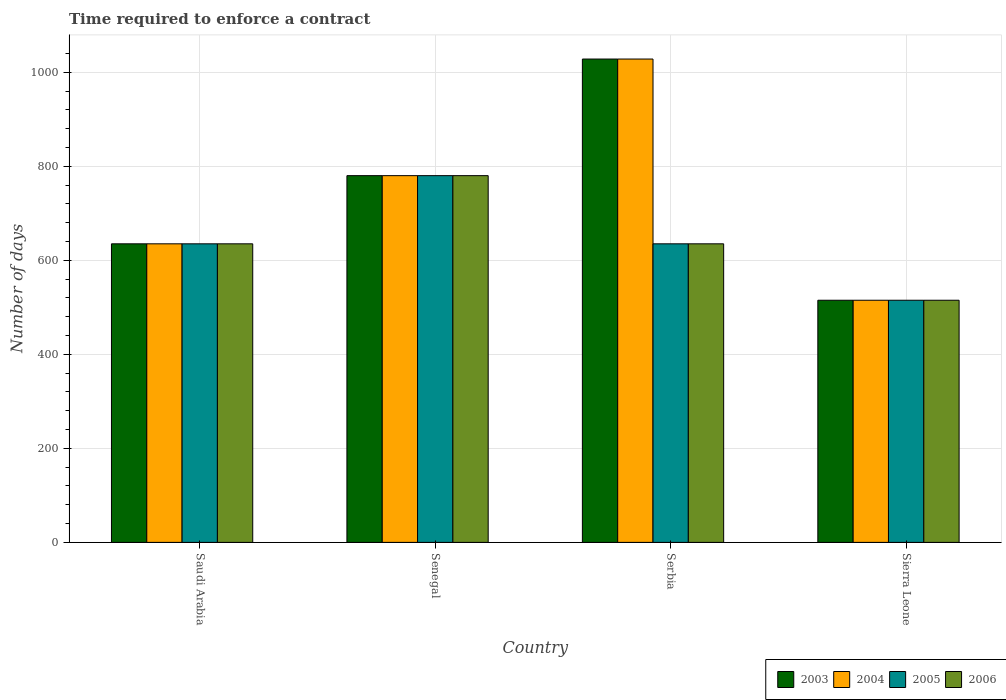How many different coloured bars are there?
Offer a very short reply. 4. What is the label of the 1st group of bars from the left?
Give a very brief answer. Saudi Arabia. In how many cases, is the number of bars for a given country not equal to the number of legend labels?
Offer a very short reply. 0. What is the number of days required to enforce a contract in 2004 in Serbia?
Your answer should be compact. 1028. Across all countries, what is the maximum number of days required to enforce a contract in 2003?
Offer a very short reply. 1028. Across all countries, what is the minimum number of days required to enforce a contract in 2003?
Give a very brief answer. 515. In which country was the number of days required to enforce a contract in 2003 maximum?
Provide a short and direct response. Serbia. In which country was the number of days required to enforce a contract in 2005 minimum?
Keep it short and to the point. Sierra Leone. What is the total number of days required to enforce a contract in 2006 in the graph?
Make the answer very short. 2565. What is the difference between the number of days required to enforce a contract in 2006 in Senegal and that in Sierra Leone?
Make the answer very short. 265. What is the difference between the number of days required to enforce a contract in 2005 in Saudi Arabia and the number of days required to enforce a contract in 2004 in Serbia?
Provide a succinct answer. -393. What is the average number of days required to enforce a contract in 2006 per country?
Offer a terse response. 641.25. In how many countries, is the number of days required to enforce a contract in 2006 greater than 560 days?
Ensure brevity in your answer.  3. What is the ratio of the number of days required to enforce a contract in 2006 in Senegal to that in Serbia?
Keep it short and to the point. 1.23. What is the difference between the highest and the second highest number of days required to enforce a contract in 2003?
Provide a short and direct response. -393. What is the difference between the highest and the lowest number of days required to enforce a contract in 2006?
Offer a terse response. 265. Is the sum of the number of days required to enforce a contract in 2004 in Saudi Arabia and Senegal greater than the maximum number of days required to enforce a contract in 2005 across all countries?
Your response must be concise. Yes. What does the 1st bar from the left in Saudi Arabia represents?
Keep it short and to the point. 2003. What does the 4th bar from the right in Senegal represents?
Provide a short and direct response. 2003. Is it the case that in every country, the sum of the number of days required to enforce a contract in 2004 and number of days required to enforce a contract in 2006 is greater than the number of days required to enforce a contract in 2005?
Offer a terse response. Yes. Where does the legend appear in the graph?
Your answer should be very brief. Bottom right. How many legend labels are there?
Give a very brief answer. 4. How are the legend labels stacked?
Give a very brief answer. Horizontal. What is the title of the graph?
Your response must be concise. Time required to enforce a contract. Does "2005" appear as one of the legend labels in the graph?
Provide a short and direct response. Yes. What is the label or title of the Y-axis?
Your response must be concise. Number of days. What is the Number of days in 2003 in Saudi Arabia?
Your response must be concise. 635. What is the Number of days in 2004 in Saudi Arabia?
Provide a short and direct response. 635. What is the Number of days of 2005 in Saudi Arabia?
Offer a terse response. 635. What is the Number of days of 2006 in Saudi Arabia?
Make the answer very short. 635. What is the Number of days of 2003 in Senegal?
Your answer should be very brief. 780. What is the Number of days of 2004 in Senegal?
Your answer should be compact. 780. What is the Number of days in 2005 in Senegal?
Your answer should be very brief. 780. What is the Number of days in 2006 in Senegal?
Your answer should be very brief. 780. What is the Number of days of 2003 in Serbia?
Provide a succinct answer. 1028. What is the Number of days of 2004 in Serbia?
Provide a succinct answer. 1028. What is the Number of days in 2005 in Serbia?
Give a very brief answer. 635. What is the Number of days in 2006 in Serbia?
Offer a very short reply. 635. What is the Number of days of 2003 in Sierra Leone?
Your response must be concise. 515. What is the Number of days in 2004 in Sierra Leone?
Make the answer very short. 515. What is the Number of days of 2005 in Sierra Leone?
Your answer should be compact. 515. What is the Number of days in 2006 in Sierra Leone?
Offer a very short reply. 515. Across all countries, what is the maximum Number of days in 2003?
Keep it short and to the point. 1028. Across all countries, what is the maximum Number of days in 2004?
Provide a short and direct response. 1028. Across all countries, what is the maximum Number of days of 2005?
Keep it short and to the point. 780. Across all countries, what is the maximum Number of days in 2006?
Offer a terse response. 780. Across all countries, what is the minimum Number of days of 2003?
Ensure brevity in your answer.  515. Across all countries, what is the minimum Number of days of 2004?
Give a very brief answer. 515. Across all countries, what is the minimum Number of days in 2005?
Ensure brevity in your answer.  515. Across all countries, what is the minimum Number of days in 2006?
Give a very brief answer. 515. What is the total Number of days in 2003 in the graph?
Offer a very short reply. 2958. What is the total Number of days in 2004 in the graph?
Keep it short and to the point. 2958. What is the total Number of days of 2005 in the graph?
Offer a very short reply. 2565. What is the total Number of days in 2006 in the graph?
Give a very brief answer. 2565. What is the difference between the Number of days in 2003 in Saudi Arabia and that in Senegal?
Offer a very short reply. -145. What is the difference between the Number of days in 2004 in Saudi Arabia and that in Senegal?
Your answer should be compact. -145. What is the difference between the Number of days in 2005 in Saudi Arabia and that in Senegal?
Offer a terse response. -145. What is the difference between the Number of days of 2006 in Saudi Arabia and that in Senegal?
Your response must be concise. -145. What is the difference between the Number of days of 2003 in Saudi Arabia and that in Serbia?
Provide a short and direct response. -393. What is the difference between the Number of days in 2004 in Saudi Arabia and that in Serbia?
Make the answer very short. -393. What is the difference between the Number of days in 2005 in Saudi Arabia and that in Serbia?
Your answer should be very brief. 0. What is the difference between the Number of days in 2006 in Saudi Arabia and that in Serbia?
Make the answer very short. 0. What is the difference between the Number of days of 2003 in Saudi Arabia and that in Sierra Leone?
Your answer should be very brief. 120. What is the difference between the Number of days in 2004 in Saudi Arabia and that in Sierra Leone?
Provide a short and direct response. 120. What is the difference between the Number of days of 2005 in Saudi Arabia and that in Sierra Leone?
Your answer should be compact. 120. What is the difference between the Number of days of 2006 in Saudi Arabia and that in Sierra Leone?
Ensure brevity in your answer.  120. What is the difference between the Number of days of 2003 in Senegal and that in Serbia?
Your response must be concise. -248. What is the difference between the Number of days in 2004 in Senegal and that in Serbia?
Provide a succinct answer. -248. What is the difference between the Number of days in 2005 in Senegal and that in Serbia?
Your answer should be very brief. 145. What is the difference between the Number of days in 2006 in Senegal and that in Serbia?
Provide a short and direct response. 145. What is the difference between the Number of days in 2003 in Senegal and that in Sierra Leone?
Offer a terse response. 265. What is the difference between the Number of days of 2004 in Senegal and that in Sierra Leone?
Ensure brevity in your answer.  265. What is the difference between the Number of days of 2005 in Senegal and that in Sierra Leone?
Provide a succinct answer. 265. What is the difference between the Number of days in 2006 in Senegal and that in Sierra Leone?
Make the answer very short. 265. What is the difference between the Number of days of 2003 in Serbia and that in Sierra Leone?
Your answer should be compact. 513. What is the difference between the Number of days of 2004 in Serbia and that in Sierra Leone?
Give a very brief answer. 513. What is the difference between the Number of days in 2005 in Serbia and that in Sierra Leone?
Offer a very short reply. 120. What is the difference between the Number of days of 2006 in Serbia and that in Sierra Leone?
Provide a short and direct response. 120. What is the difference between the Number of days of 2003 in Saudi Arabia and the Number of days of 2004 in Senegal?
Your response must be concise. -145. What is the difference between the Number of days in 2003 in Saudi Arabia and the Number of days in 2005 in Senegal?
Provide a short and direct response. -145. What is the difference between the Number of days in 2003 in Saudi Arabia and the Number of days in 2006 in Senegal?
Your response must be concise. -145. What is the difference between the Number of days in 2004 in Saudi Arabia and the Number of days in 2005 in Senegal?
Offer a very short reply. -145. What is the difference between the Number of days in 2004 in Saudi Arabia and the Number of days in 2006 in Senegal?
Ensure brevity in your answer.  -145. What is the difference between the Number of days of 2005 in Saudi Arabia and the Number of days of 2006 in Senegal?
Provide a short and direct response. -145. What is the difference between the Number of days in 2003 in Saudi Arabia and the Number of days in 2004 in Serbia?
Keep it short and to the point. -393. What is the difference between the Number of days in 2003 in Saudi Arabia and the Number of days in 2005 in Serbia?
Offer a very short reply. 0. What is the difference between the Number of days of 2005 in Saudi Arabia and the Number of days of 2006 in Serbia?
Keep it short and to the point. 0. What is the difference between the Number of days of 2003 in Saudi Arabia and the Number of days of 2004 in Sierra Leone?
Provide a short and direct response. 120. What is the difference between the Number of days of 2003 in Saudi Arabia and the Number of days of 2005 in Sierra Leone?
Offer a very short reply. 120. What is the difference between the Number of days of 2003 in Saudi Arabia and the Number of days of 2006 in Sierra Leone?
Offer a terse response. 120. What is the difference between the Number of days in 2004 in Saudi Arabia and the Number of days in 2005 in Sierra Leone?
Provide a short and direct response. 120. What is the difference between the Number of days in 2004 in Saudi Arabia and the Number of days in 2006 in Sierra Leone?
Provide a short and direct response. 120. What is the difference between the Number of days in 2005 in Saudi Arabia and the Number of days in 2006 in Sierra Leone?
Your response must be concise. 120. What is the difference between the Number of days of 2003 in Senegal and the Number of days of 2004 in Serbia?
Provide a succinct answer. -248. What is the difference between the Number of days in 2003 in Senegal and the Number of days in 2005 in Serbia?
Keep it short and to the point. 145. What is the difference between the Number of days in 2003 in Senegal and the Number of days in 2006 in Serbia?
Provide a succinct answer. 145. What is the difference between the Number of days of 2004 in Senegal and the Number of days of 2005 in Serbia?
Your answer should be very brief. 145. What is the difference between the Number of days in 2004 in Senegal and the Number of days in 2006 in Serbia?
Give a very brief answer. 145. What is the difference between the Number of days of 2005 in Senegal and the Number of days of 2006 in Serbia?
Offer a terse response. 145. What is the difference between the Number of days of 2003 in Senegal and the Number of days of 2004 in Sierra Leone?
Your answer should be very brief. 265. What is the difference between the Number of days in 2003 in Senegal and the Number of days in 2005 in Sierra Leone?
Ensure brevity in your answer.  265. What is the difference between the Number of days in 2003 in Senegal and the Number of days in 2006 in Sierra Leone?
Offer a terse response. 265. What is the difference between the Number of days in 2004 in Senegal and the Number of days in 2005 in Sierra Leone?
Your answer should be very brief. 265. What is the difference between the Number of days in 2004 in Senegal and the Number of days in 2006 in Sierra Leone?
Provide a succinct answer. 265. What is the difference between the Number of days in 2005 in Senegal and the Number of days in 2006 in Sierra Leone?
Provide a succinct answer. 265. What is the difference between the Number of days in 2003 in Serbia and the Number of days in 2004 in Sierra Leone?
Make the answer very short. 513. What is the difference between the Number of days in 2003 in Serbia and the Number of days in 2005 in Sierra Leone?
Ensure brevity in your answer.  513. What is the difference between the Number of days in 2003 in Serbia and the Number of days in 2006 in Sierra Leone?
Offer a very short reply. 513. What is the difference between the Number of days of 2004 in Serbia and the Number of days of 2005 in Sierra Leone?
Your response must be concise. 513. What is the difference between the Number of days in 2004 in Serbia and the Number of days in 2006 in Sierra Leone?
Make the answer very short. 513. What is the difference between the Number of days of 2005 in Serbia and the Number of days of 2006 in Sierra Leone?
Offer a terse response. 120. What is the average Number of days of 2003 per country?
Offer a very short reply. 739.5. What is the average Number of days of 2004 per country?
Your answer should be very brief. 739.5. What is the average Number of days in 2005 per country?
Offer a terse response. 641.25. What is the average Number of days in 2006 per country?
Provide a short and direct response. 641.25. What is the difference between the Number of days of 2003 and Number of days of 2005 in Saudi Arabia?
Offer a terse response. 0. What is the difference between the Number of days in 2003 and Number of days in 2006 in Saudi Arabia?
Provide a succinct answer. 0. What is the difference between the Number of days of 2004 and Number of days of 2005 in Saudi Arabia?
Provide a short and direct response. 0. What is the difference between the Number of days in 2003 and Number of days in 2005 in Senegal?
Your response must be concise. 0. What is the difference between the Number of days in 2004 and Number of days in 2006 in Senegal?
Your answer should be very brief. 0. What is the difference between the Number of days in 2003 and Number of days in 2004 in Serbia?
Ensure brevity in your answer.  0. What is the difference between the Number of days in 2003 and Number of days in 2005 in Serbia?
Provide a short and direct response. 393. What is the difference between the Number of days in 2003 and Number of days in 2006 in Serbia?
Your answer should be compact. 393. What is the difference between the Number of days in 2004 and Number of days in 2005 in Serbia?
Offer a very short reply. 393. What is the difference between the Number of days of 2004 and Number of days of 2006 in Serbia?
Give a very brief answer. 393. What is the difference between the Number of days in 2005 and Number of days in 2006 in Serbia?
Provide a succinct answer. 0. What is the difference between the Number of days of 2003 and Number of days of 2004 in Sierra Leone?
Your answer should be compact. 0. What is the difference between the Number of days of 2003 and Number of days of 2006 in Sierra Leone?
Your response must be concise. 0. What is the difference between the Number of days in 2004 and Number of days in 2005 in Sierra Leone?
Offer a terse response. 0. What is the difference between the Number of days of 2005 and Number of days of 2006 in Sierra Leone?
Your answer should be very brief. 0. What is the ratio of the Number of days of 2003 in Saudi Arabia to that in Senegal?
Provide a short and direct response. 0.81. What is the ratio of the Number of days in 2004 in Saudi Arabia to that in Senegal?
Your answer should be compact. 0.81. What is the ratio of the Number of days of 2005 in Saudi Arabia to that in Senegal?
Your answer should be very brief. 0.81. What is the ratio of the Number of days of 2006 in Saudi Arabia to that in Senegal?
Give a very brief answer. 0.81. What is the ratio of the Number of days of 2003 in Saudi Arabia to that in Serbia?
Your answer should be very brief. 0.62. What is the ratio of the Number of days of 2004 in Saudi Arabia to that in Serbia?
Provide a succinct answer. 0.62. What is the ratio of the Number of days in 2005 in Saudi Arabia to that in Serbia?
Your answer should be very brief. 1. What is the ratio of the Number of days in 2006 in Saudi Arabia to that in Serbia?
Make the answer very short. 1. What is the ratio of the Number of days in 2003 in Saudi Arabia to that in Sierra Leone?
Ensure brevity in your answer.  1.23. What is the ratio of the Number of days in 2004 in Saudi Arabia to that in Sierra Leone?
Offer a very short reply. 1.23. What is the ratio of the Number of days in 2005 in Saudi Arabia to that in Sierra Leone?
Your answer should be very brief. 1.23. What is the ratio of the Number of days of 2006 in Saudi Arabia to that in Sierra Leone?
Keep it short and to the point. 1.23. What is the ratio of the Number of days in 2003 in Senegal to that in Serbia?
Give a very brief answer. 0.76. What is the ratio of the Number of days in 2004 in Senegal to that in Serbia?
Ensure brevity in your answer.  0.76. What is the ratio of the Number of days in 2005 in Senegal to that in Serbia?
Provide a short and direct response. 1.23. What is the ratio of the Number of days in 2006 in Senegal to that in Serbia?
Keep it short and to the point. 1.23. What is the ratio of the Number of days in 2003 in Senegal to that in Sierra Leone?
Your answer should be very brief. 1.51. What is the ratio of the Number of days in 2004 in Senegal to that in Sierra Leone?
Make the answer very short. 1.51. What is the ratio of the Number of days of 2005 in Senegal to that in Sierra Leone?
Keep it short and to the point. 1.51. What is the ratio of the Number of days in 2006 in Senegal to that in Sierra Leone?
Provide a succinct answer. 1.51. What is the ratio of the Number of days in 2003 in Serbia to that in Sierra Leone?
Make the answer very short. 2. What is the ratio of the Number of days of 2004 in Serbia to that in Sierra Leone?
Provide a short and direct response. 2. What is the ratio of the Number of days of 2005 in Serbia to that in Sierra Leone?
Offer a terse response. 1.23. What is the ratio of the Number of days of 2006 in Serbia to that in Sierra Leone?
Give a very brief answer. 1.23. What is the difference between the highest and the second highest Number of days of 2003?
Offer a very short reply. 248. What is the difference between the highest and the second highest Number of days in 2004?
Your response must be concise. 248. What is the difference between the highest and the second highest Number of days of 2005?
Your response must be concise. 145. What is the difference between the highest and the second highest Number of days in 2006?
Your response must be concise. 145. What is the difference between the highest and the lowest Number of days in 2003?
Make the answer very short. 513. What is the difference between the highest and the lowest Number of days of 2004?
Ensure brevity in your answer.  513. What is the difference between the highest and the lowest Number of days of 2005?
Give a very brief answer. 265. What is the difference between the highest and the lowest Number of days of 2006?
Your response must be concise. 265. 